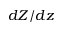Convert formula to latex. <formula><loc_0><loc_0><loc_500><loc_500>d Z / d z</formula> 